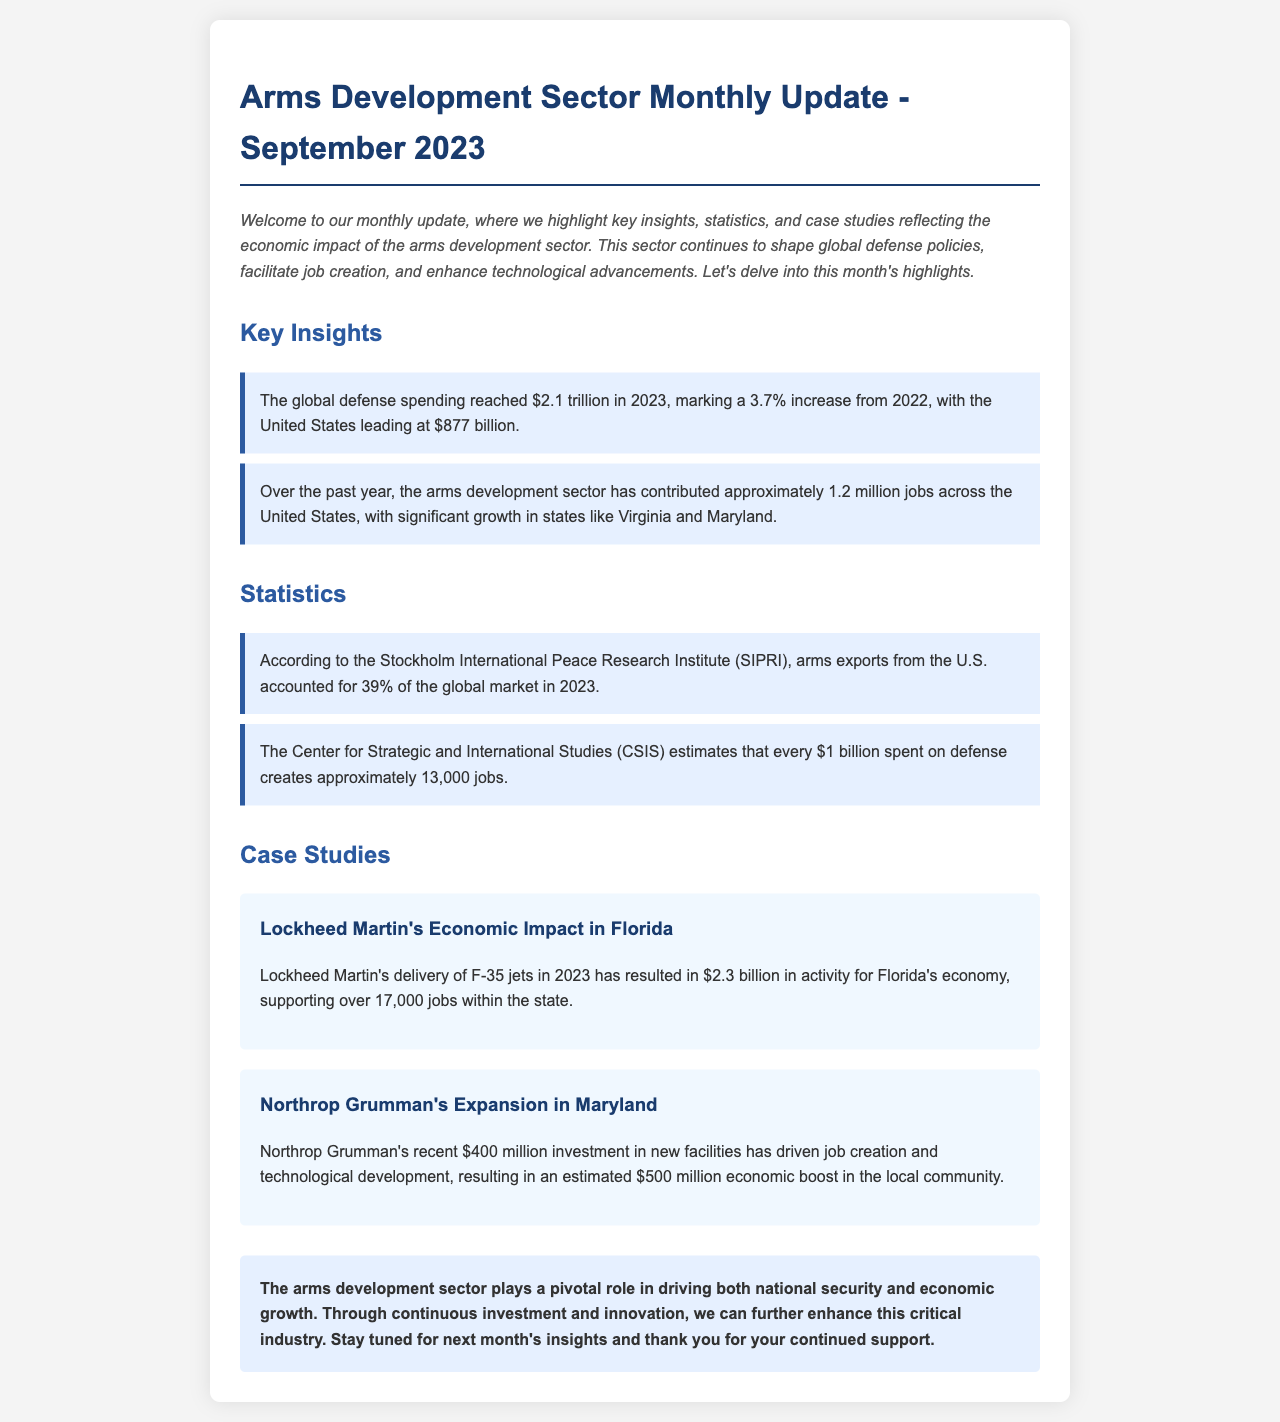What was the global defense spending in 2023? The document states that global defense spending reached $2.1 trillion in 2023.
Answer: $2.1 trillion How many jobs did the arms development sector contribute in the past year? According to the information, the arms development sector has contributed approximately 1.2 million jobs across the United States.
Answer: 1.2 million jobs What percentage of the global arms market did U.S. arms exports account for in 2023? The document mentions that arms exports from the U.S. accounted for 39% of the global market in 2023.
Answer: 39% How many jobs does every $1 billion spent on defense create? The document states that every $1 billion spent on defense creates approximately 13,000 jobs.
Answer: 13,000 jobs What economic activity did Lockheed Martin generate in Florida in 2023? According to the case study, Lockheed Martin generated $2.3 billion in activity for Florida's economy.
Answer: $2.3 billion What was Northrop Grumman's recent investment amount in Maryland? The document indicates that Northrop Grumman's recent investment in new facilities was $400 million.
Answer: $400 million Which state saw significant growth in jobs due to the arms development sector? The text highlights that significant job growth occurred in states like Virginia and Maryland.
Answer: Virginia and Maryland What is the conclusion about the role of the arms development sector? The conclusion emphasizes that the arms development sector plays a pivotal role in driving both national security and economic growth.
Answer: Pivotal role in national security and economic growth 